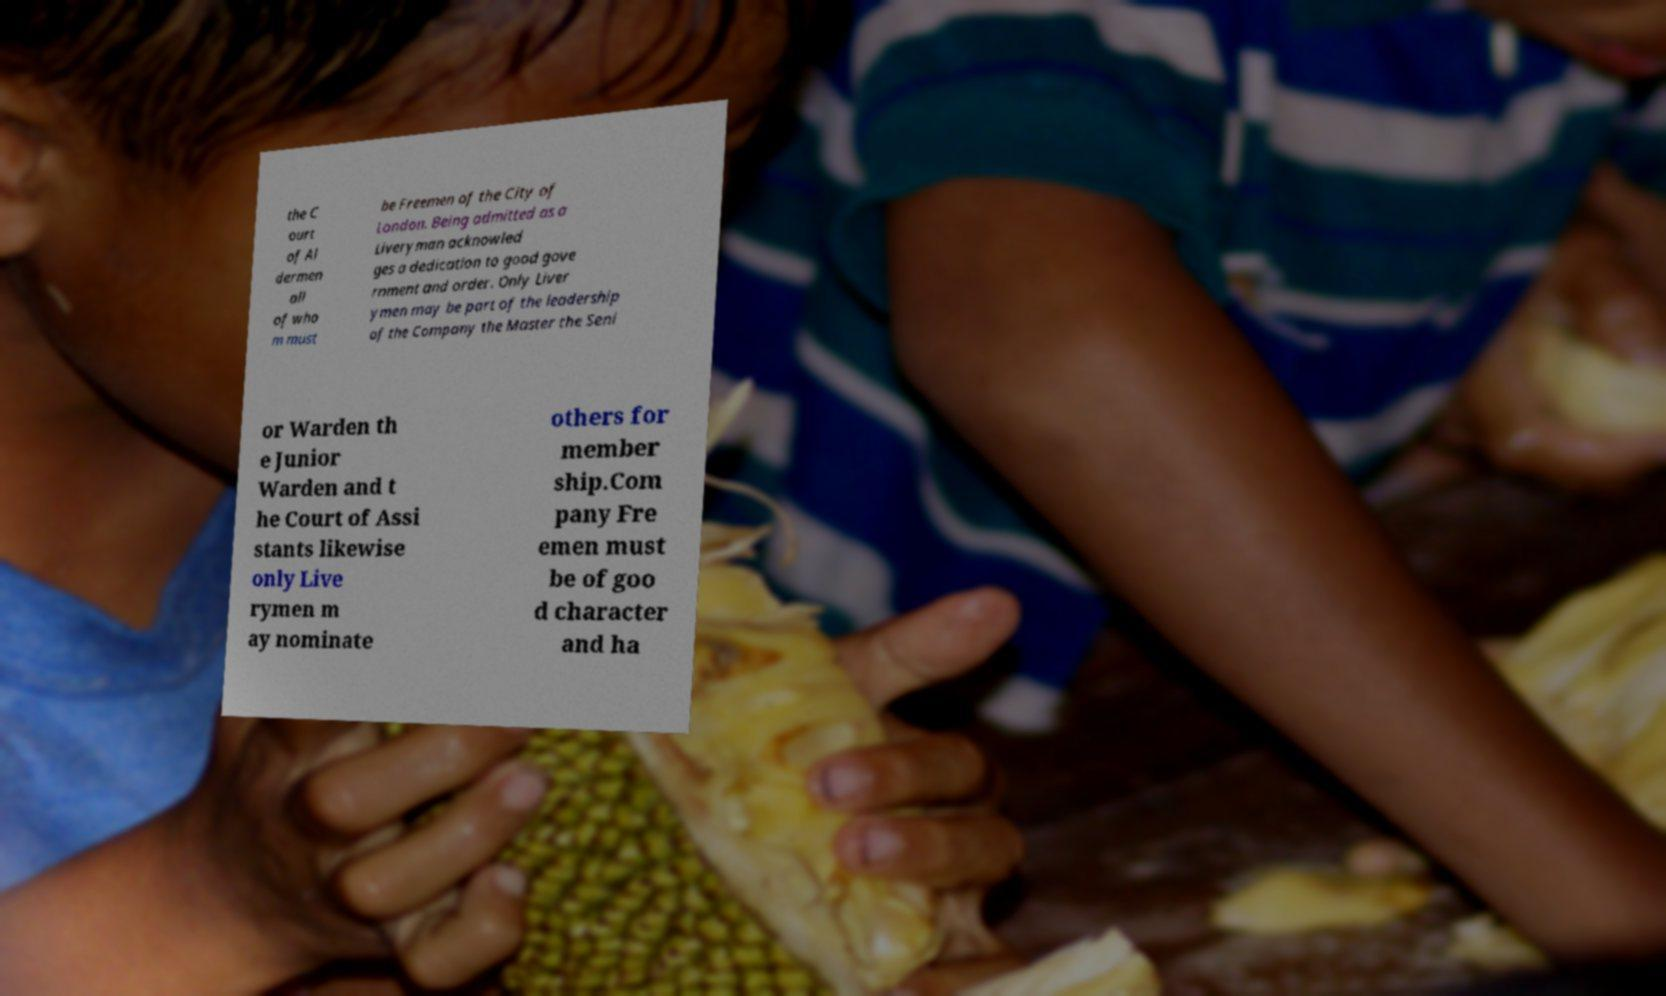For documentation purposes, I need the text within this image transcribed. Could you provide that? the C ourt of Al dermen all of who m must be Freemen of the City of London. Being admitted as a Liveryman acknowled ges a dedication to good gove rnment and order. Only Liver ymen may be part of the leadership of the Company the Master the Seni or Warden th e Junior Warden and t he Court of Assi stants likewise only Live rymen m ay nominate others for member ship.Com pany Fre emen must be of goo d character and ha 